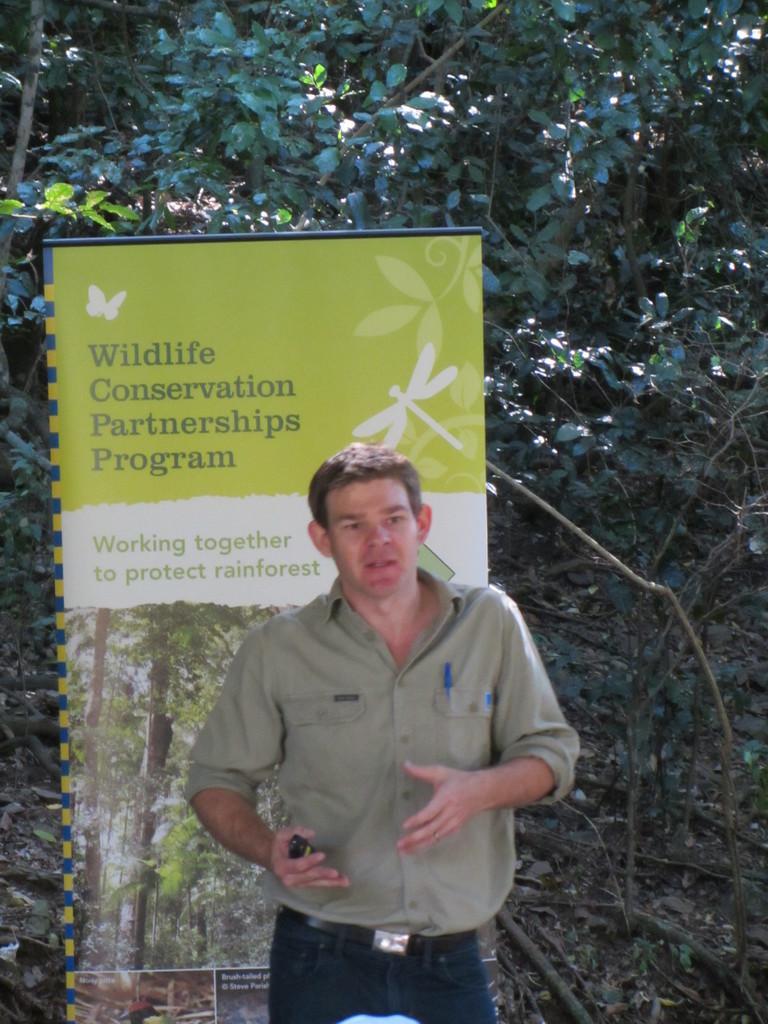Describe this image in one or two sentences. In the image we can see a man standing, wearing clothes and holding an object in hand. Here we can see the poster and text on the poster. Here we can see dry leaves and trees. 